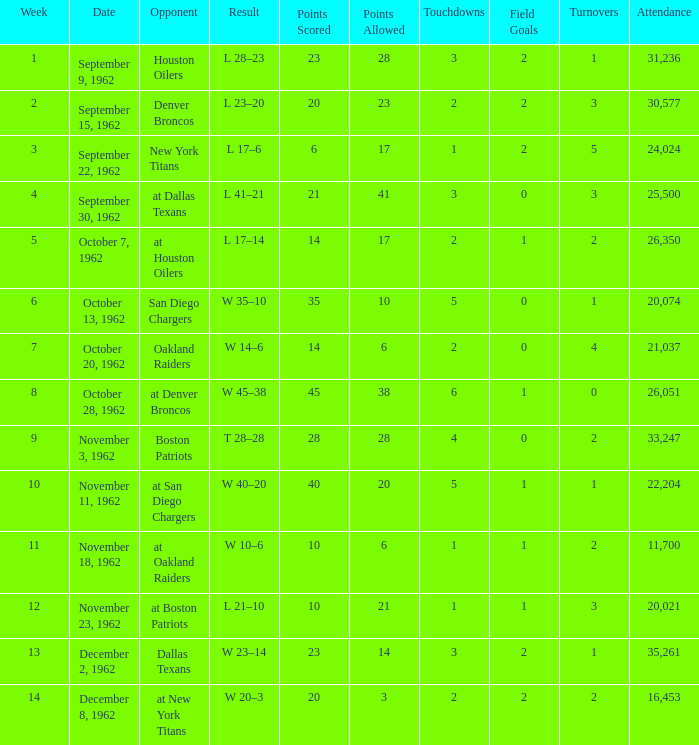What week was the attendance smaller than 22,204 on December 8, 1962? 14.0. 